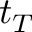<formula> <loc_0><loc_0><loc_500><loc_500>t _ { T }</formula> 